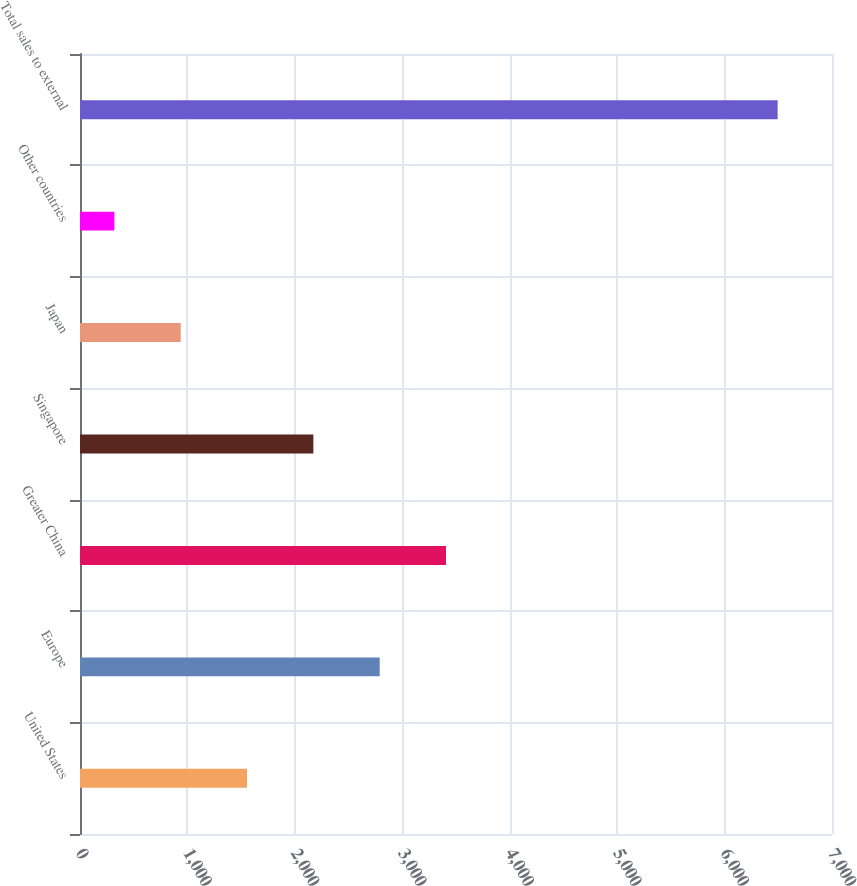<chart> <loc_0><loc_0><loc_500><loc_500><bar_chart><fcel>United States<fcel>Europe<fcel>Greater China<fcel>Singapore<fcel>Japan<fcel>Other countries<fcel>Total sales to external<nl><fcel>1554.8<fcel>2789.6<fcel>3407<fcel>2172.2<fcel>937.4<fcel>320<fcel>6494<nl></chart> 